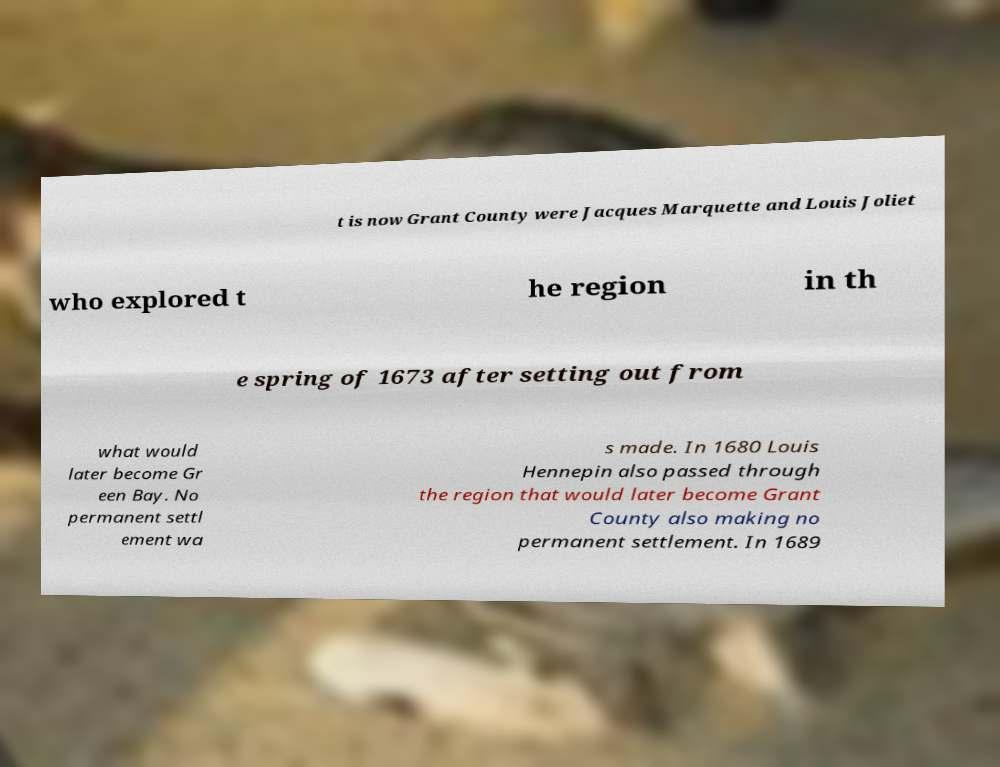Could you extract and type out the text from this image? t is now Grant County were Jacques Marquette and Louis Joliet who explored t he region in th e spring of 1673 after setting out from what would later become Gr een Bay. No permanent settl ement wa s made. In 1680 Louis Hennepin also passed through the region that would later become Grant County also making no permanent settlement. In 1689 